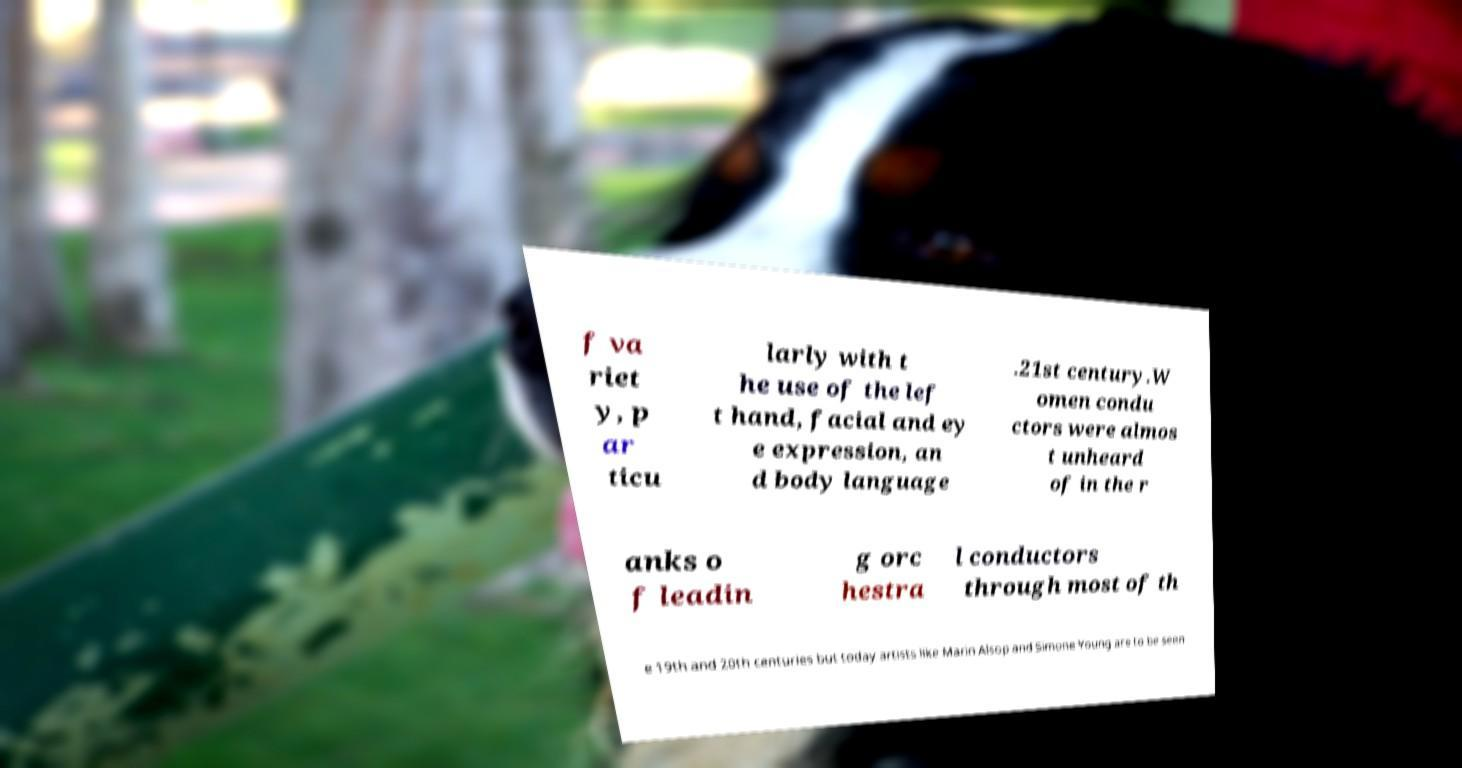There's text embedded in this image that I need extracted. Can you transcribe it verbatim? f va riet y, p ar ticu larly with t he use of the lef t hand, facial and ey e expression, an d body language .21st century.W omen condu ctors were almos t unheard of in the r anks o f leadin g orc hestra l conductors through most of th e 19th and 20th centuries but today artists like Marin Alsop and Simone Young are to be seen 